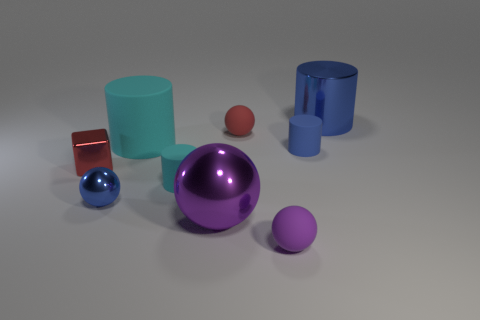How many blue cylinders must be subtracted to get 1 blue cylinders? 1 Subtract all large purple shiny spheres. How many spheres are left? 3 Subtract all purple blocks. How many blue cylinders are left? 2 Subtract all blocks. How many objects are left? 8 Subtract 2 spheres. How many spheres are left? 2 Subtract all cyan cylinders. How many cylinders are left? 2 Add 4 big spheres. How many big spheres are left? 5 Add 1 metallic blocks. How many metallic blocks exist? 2 Subtract 1 blue balls. How many objects are left? 8 Subtract all blue cylinders. Subtract all brown blocks. How many cylinders are left? 2 